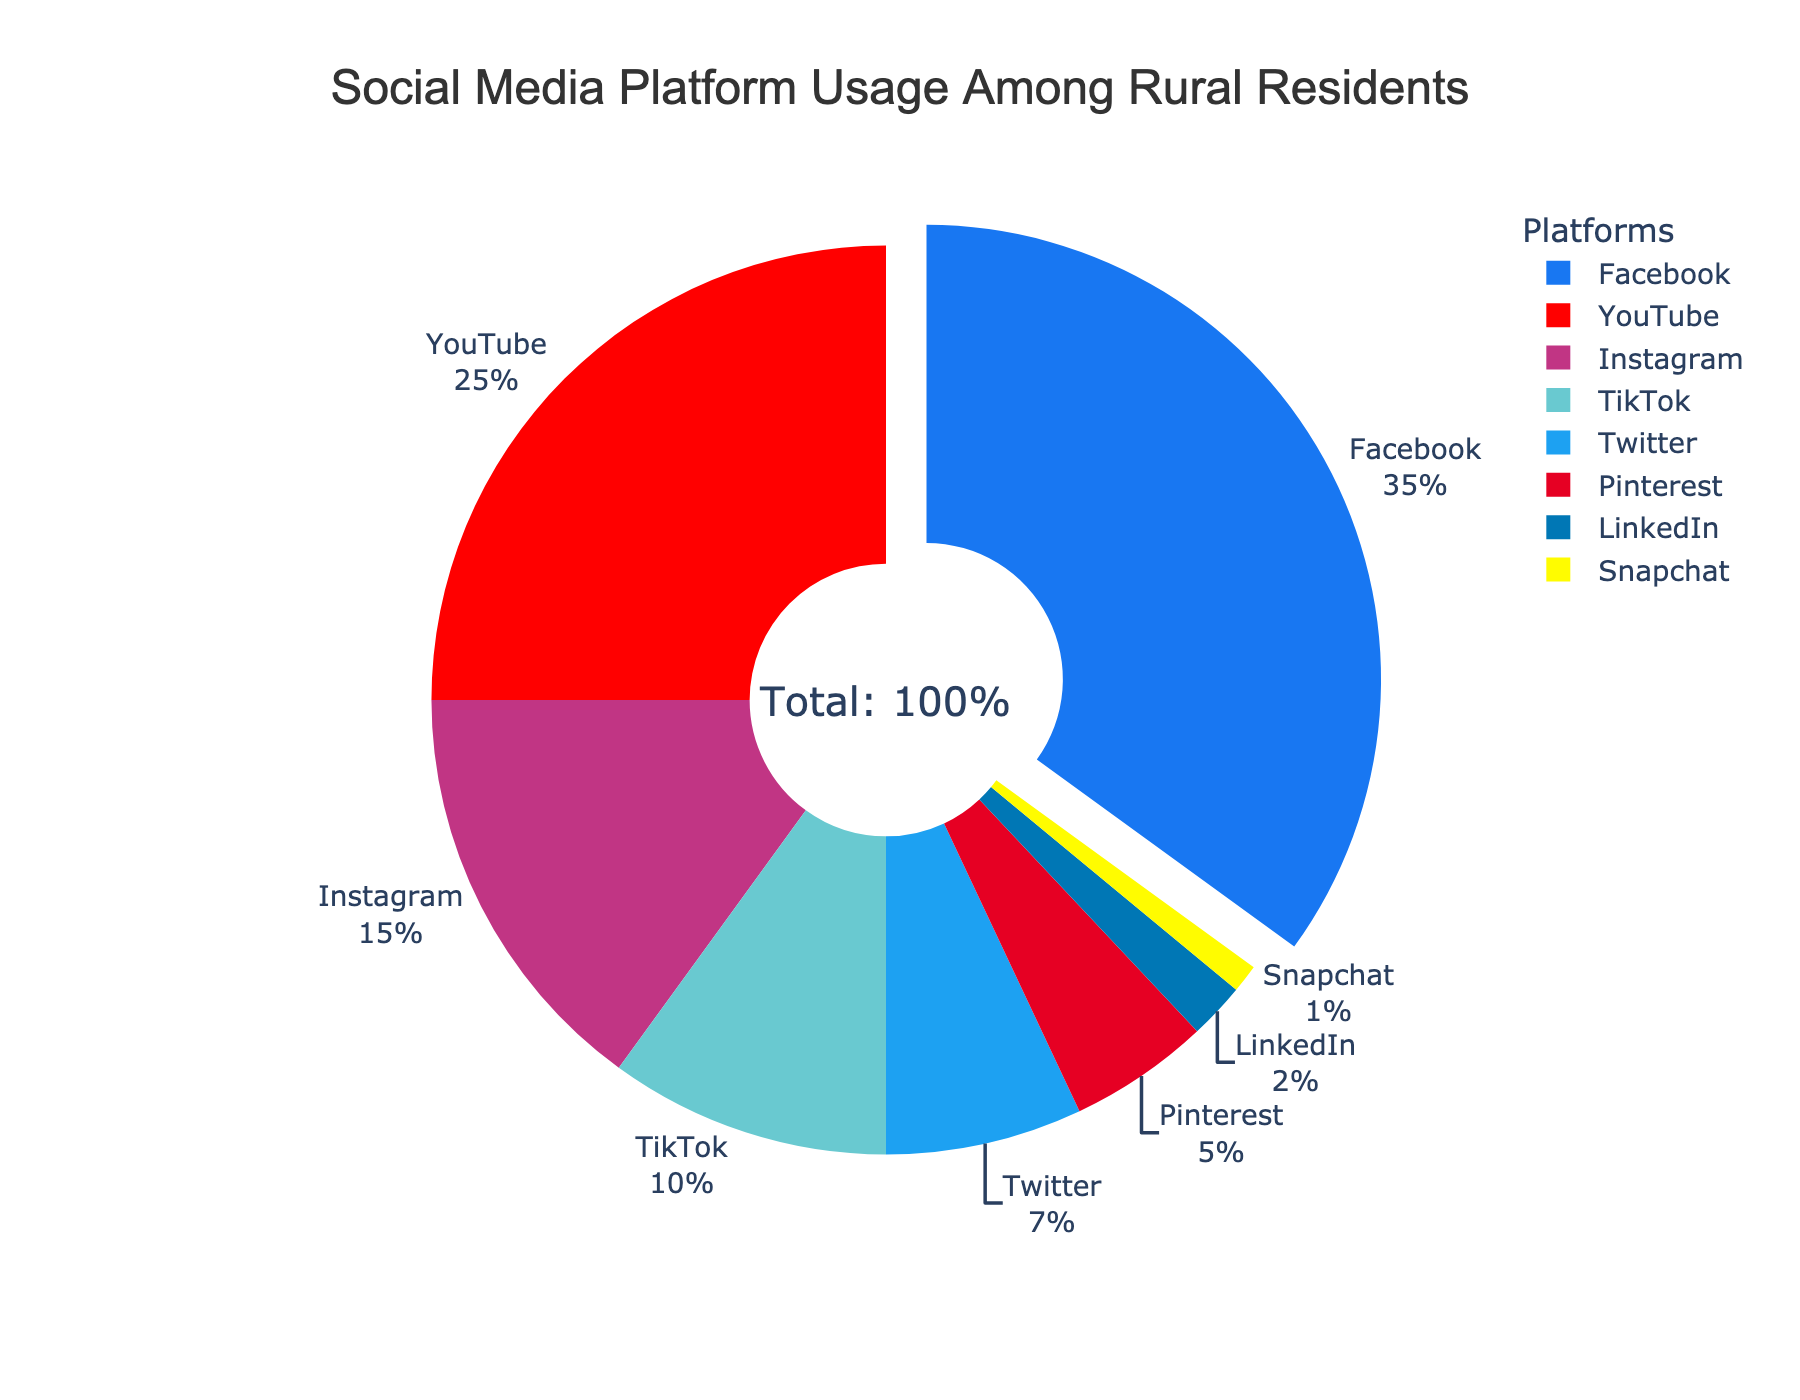What percentage of rural residents use YouTube? Look at the segment labeled "YouTube" to determine its percentage of the total usage.
Answer: 25% Which social media platform has the lowest usage among rural residents? Identify the segment with the smallest percentage on the pie chart.
Answer: Snapchat How much higher is Facebook’s usage compared to Instagram’s? Find the percentages for Facebook and Instagram, then subtract Instagram's percentage from Facebook's. 35% (Facebook) - 15% (Instagram) = 20%
Answer: 20% What is the combined usage percentage of Twitter and Pinterest? Add the percentages of Twitter and Pinterest together. 7% (Twitter) + 5% (Pinterest) = 12%
Answer: 12% Which platforms have a combined usage of more than 40%? Add the percentages of relevant platforms and check if their total exceeds 40%. Facebook (35%) and YouTube (25%) sum to 60%, which is more than 40%.
Answer: Facebook and YouTube How does the usage of TikTok compare to LinkedIn? Find and compare the percentage values for TikTok and LinkedIn. TikTok has 10% and LinkedIn has 2%, so TikTok is higher.
Answer: TikTok is higher What percentage of rural residents use platforms other than Facebook and YouTube? Subtract the combined percentage of Facebook and YouTube from 100%. 100% - (35% + 25%) = 40%
Answer: 40% Which platform appears as the least used among the seven presented? Look at the segments and identify the smallest one which is labeled Snapchat at 1%.
Answer: Snapchat What’s the percentage difference between the most used and least used platforms? Subtract the least used platform's percentage from the most used platform's percentage. 35% (Facebook) - 1% (Snapchat) = 34%
Answer: 34% What percentage of platforms have less than 10% usage each among rural residents? Count the number of platforms with a usage percentage less than 10% and divide by the total number of platforms, then multiply by 100%. Pinterest, LinkedIn, and Snapchat have less than 10%. That's 3 out of 8 platforms, so (3/8)*100% = 37.5%.
Answer: 37.5% 